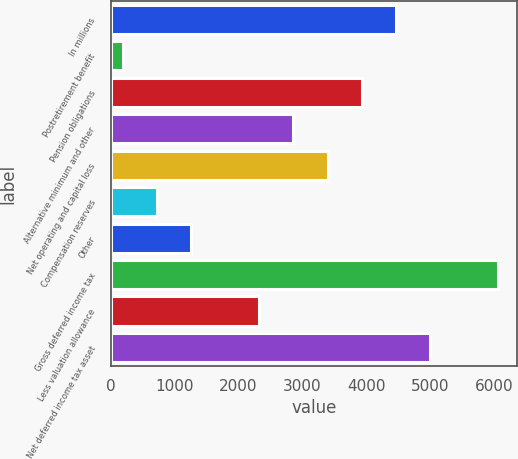Convert chart to OTSL. <chart><loc_0><loc_0><loc_500><loc_500><bar_chart><fcel>In millions<fcel>Postretirement benefit<fcel>Pension obligations<fcel>Alternative minimum and other<fcel>Net operating and capital loss<fcel>Compensation reserves<fcel>Other<fcel>Gross deferred income tax<fcel>Less valuation allowance<fcel>Net deferred income tax asset<nl><fcel>4462.6<fcel>193<fcel>3928.9<fcel>2861.5<fcel>3395.2<fcel>726.7<fcel>1260.4<fcel>6063.7<fcel>2327.8<fcel>4996.3<nl></chart> 